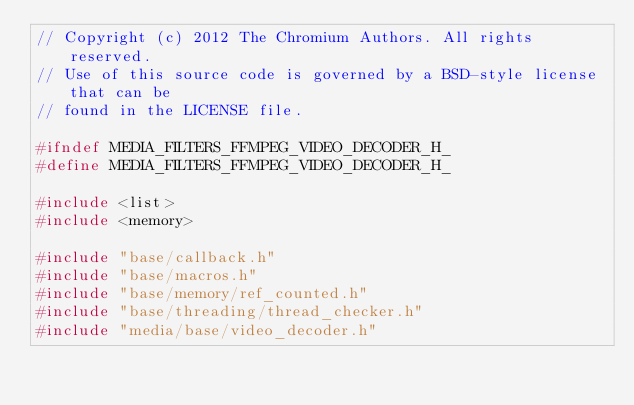<code> <loc_0><loc_0><loc_500><loc_500><_C_>// Copyright (c) 2012 The Chromium Authors. All rights reserved.
// Use of this source code is governed by a BSD-style license that can be
// found in the LICENSE file.

#ifndef MEDIA_FILTERS_FFMPEG_VIDEO_DECODER_H_
#define MEDIA_FILTERS_FFMPEG_VIDEO_DECODER_H_

#include <list>
#include <memory>

#include "base/callback.h"
#include "base/macros.h"
#include "base/memory/ref_counted.h"
#include "base/threading/thread_checker.h"
#include "media/base/video_decoder.h"</code> 